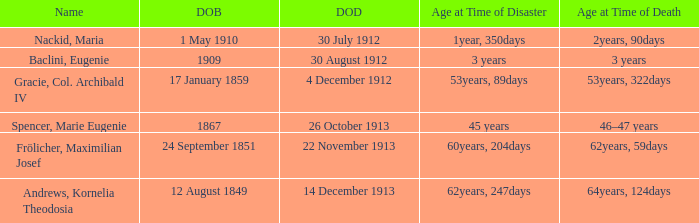When did the person born 24 September 1851 pass away? 22 November 1913. 